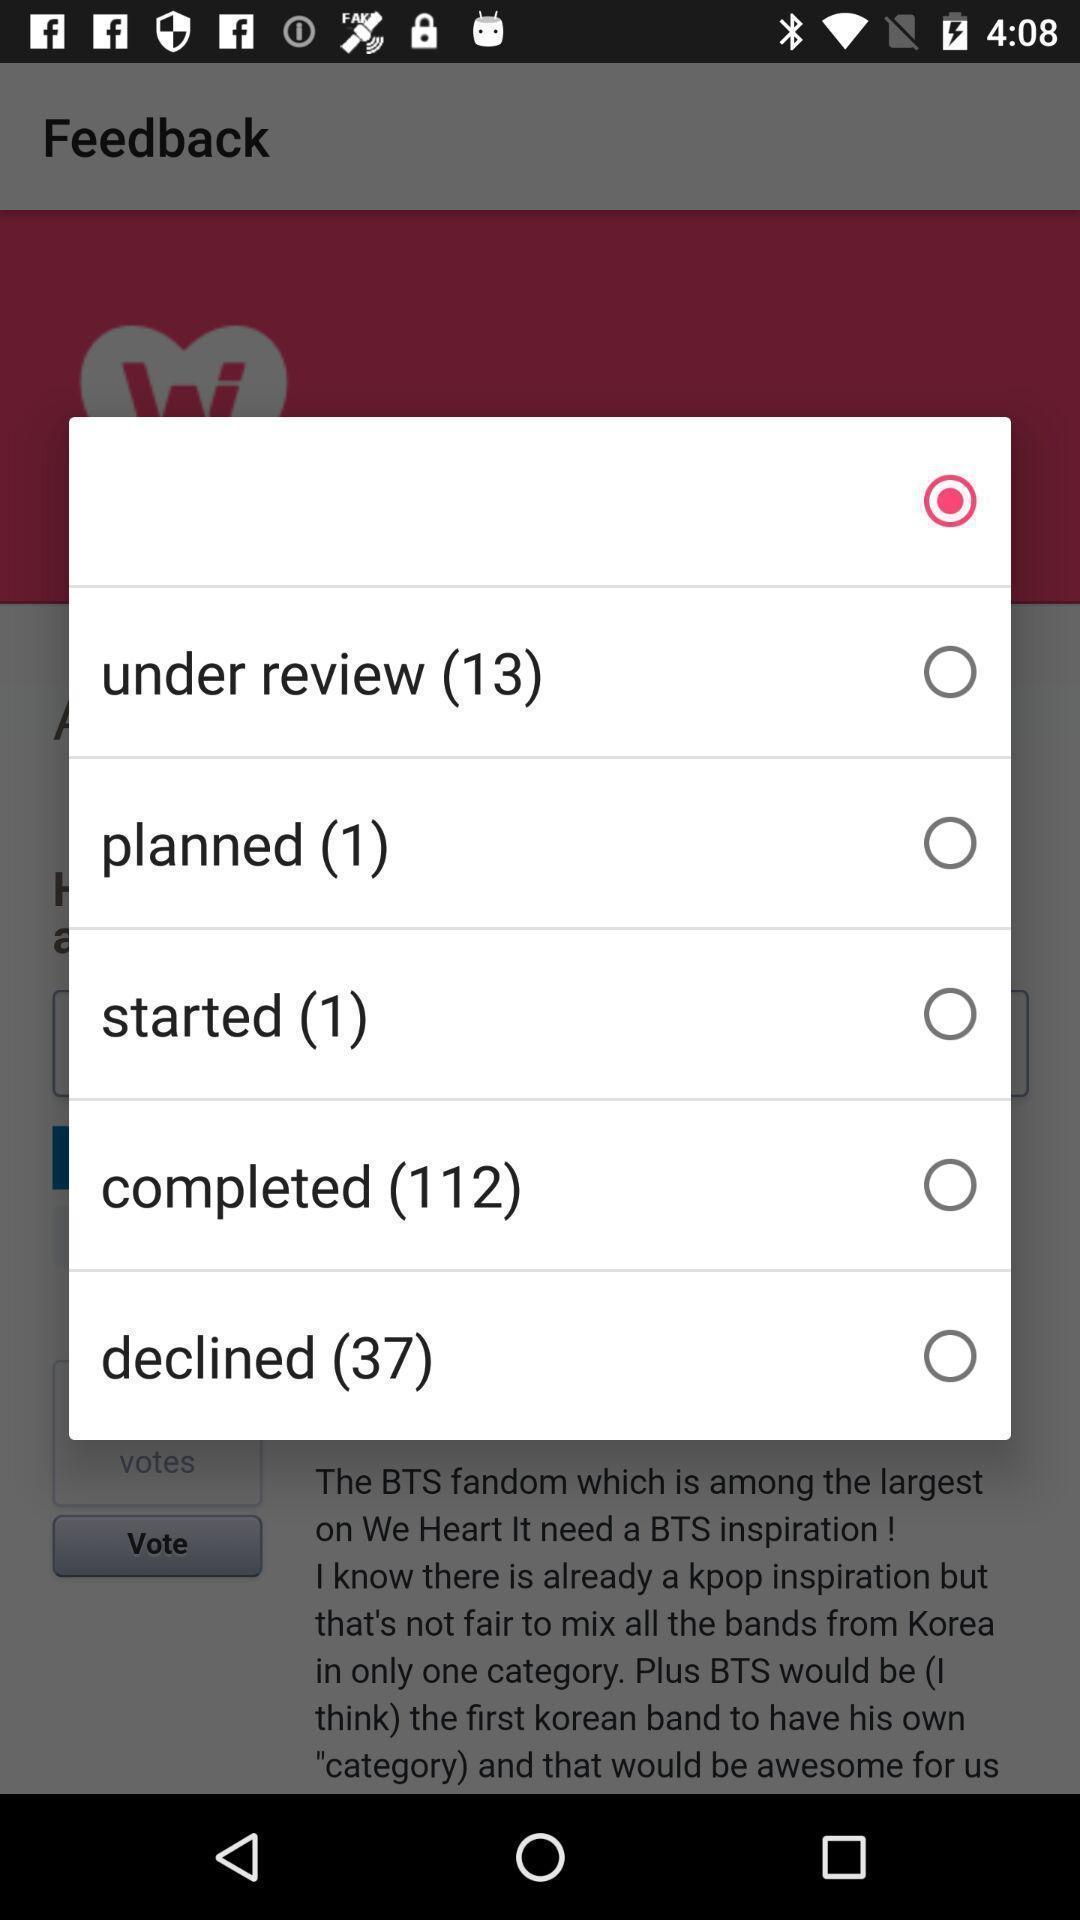Tell me what you see in this picture. Popup of different options in the application. 